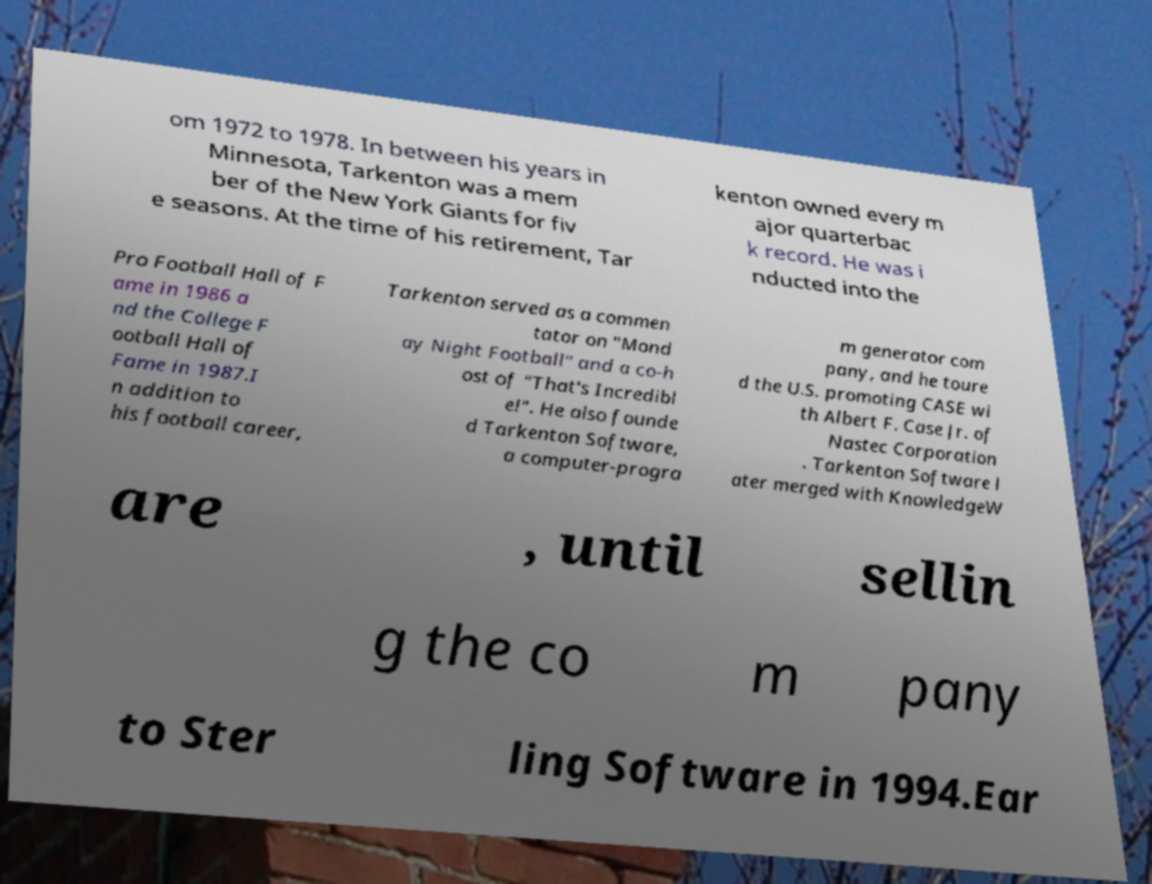Could you extract and type out the text from this image? om 1972 to 1978. In between his years in Minnesota, Tarkenton was a mem ber of the New York Giants for fiv e seasons. At the time of his retirement, Tar kenton owned every m ajor quarterbac k record. He was i nducted into the Pro Football Hall of F ame in 1986 a nd the College F ootball Hall of Fame in 1987.I n addition to his football career, Tarkenton served as a commen tator on "Mond ay Night Football" and a co-h ost of "That's Incredibl e!". He also founde d Tarkenton Software, a computer-progra m generator com pany, and he toure d the U.S. promoting CASE wi th Albert F. Case Jr. of Nastec Corporation . Tarkenton Software l ater merged with KnowledgeW are , until sellin g the co m pany to Ster ling Software in 1994.Ear 